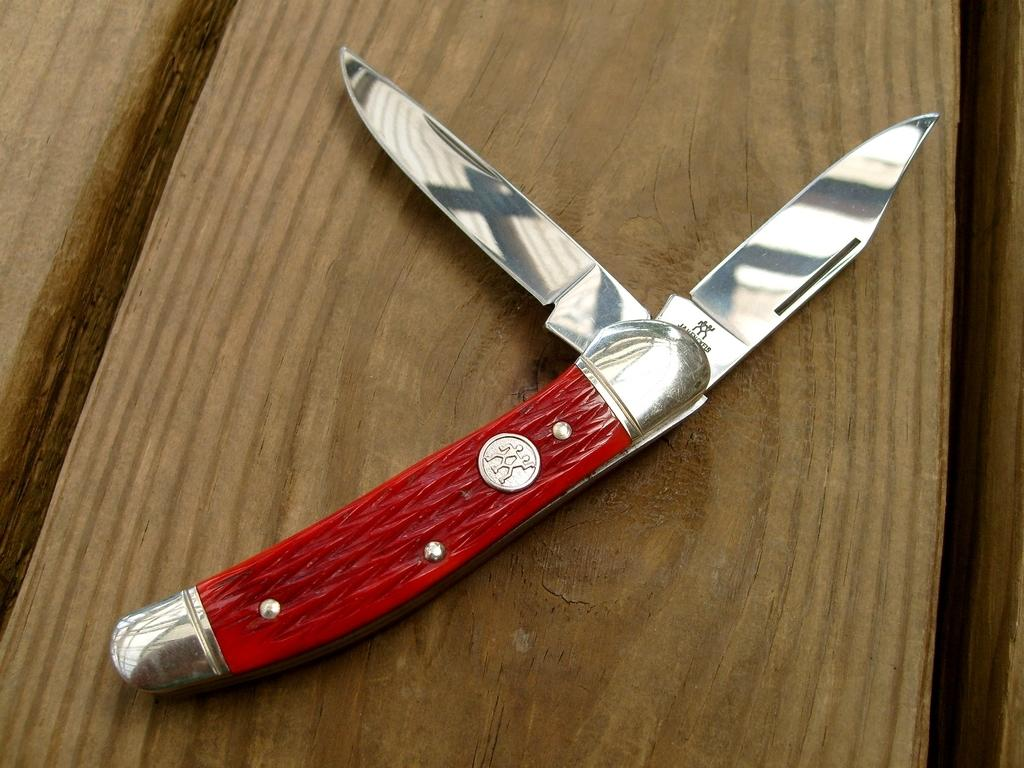What object is present on the wooden table in the image? There is a knife on the wooden table in the image. What is the color of the knife's handle? The handle of the knife is red. What time of day is it in the image, and is there a yak present? The time of day is not mentioned in the image, and there is no yak present. 